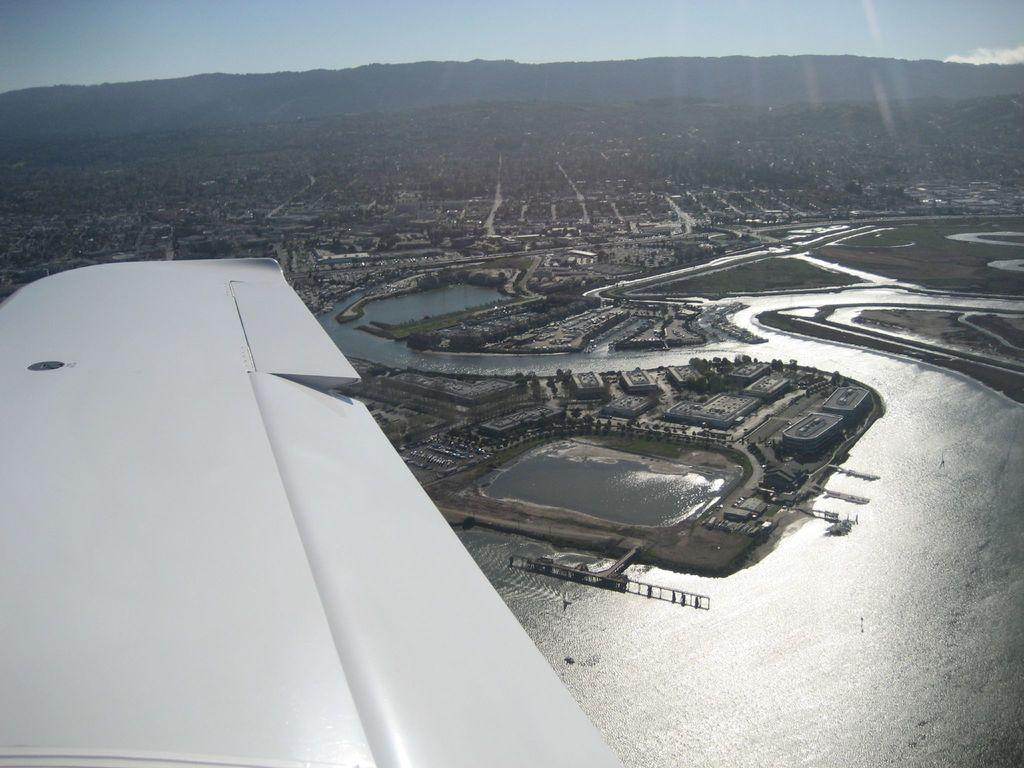What type of structures can be seen in the image? There are buildings in the image. What natural element is visible in the image? There is water visible in the image. What type of vegetation is present in the image? There is grass in the image. What geographical feature can be seen in the image? There are mountains in the image. What part of the natural environment is visible in the image? The sky is visible in the image. Can you tell me how many spades are being used to dig in the grass in the image? There are no spades visible in the image; it features buildings, water, grass, mountains, and the sky. What type of tree is growing on the mountains in the image? There are no trees visible on the mountains in the image; only the mountains themselves are present. 